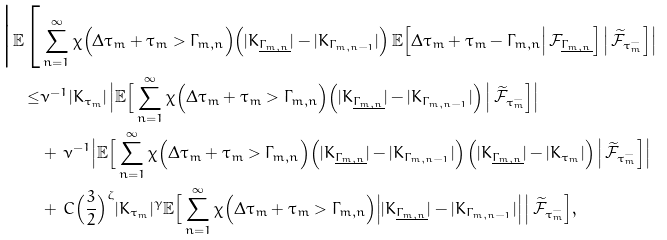<formula> <loc_0><loc_0><loc_500><loc_500>\Big | \mathbb { E } \Big [ & \sum _ { n = 1 } ^ { \infty } \chi \Big ( \Delta \tau _ { m } + \tau _ { m } > \Gamma _ { m , n } \Big ) \Big ( | K _ { \underline { \Gamma _ { m , n } } } | - | K _ { \Gamma _ { m , n - 1 } } | \Big ) \, \mathbb { E } \Big [ \Delta \tau _ { m } + \tau _ { m } - \Gamma _ { m , n } \Big | \, \mathcal { F } _ { \underline { \Gamma _ { m , n } } } \Big ] \, \Big | \, \widetilde { \mathcal { F } } _ { \tau _ { m } ^ { - } } \Big ] \Big | \\ \leq & \nu ^ { - 1 } | K _ { \tau _ { m } } | \, \Big | \mathbb { E } \Big [ \sum _ { n = 1 } ^ { \infty } \chi \Big ( \Delta \tau _ { m } + \tau _ { m } > \Gamma _ { m , n } \Big ) \Big ( | K _ { \underline { \Gamma _ { m , n } } } | - | K _ { \Gamma _ { m , n - 1 } } | \Big ) \, \Big | \, \widetilde { \mathcal { F } } _ { \tau _ { m } ^ { - } } \Big ] \Big | \\ & + \, \nu ^ { - 1 } \Big | \mathbb { E } \Big [ \sum _ { n = 1 } ^ { \infty } \chi \Big ( \Delta \tau _ { m } + \tau _ { m } > \Gamma _ { m , n } \Big ) \Big ( | K _ { \underline { \Gamma _ { m , n } } } | - | K _ { \Gamma _ { m , n - 1 } } | \Big ) \, \Big ( | K _ { \underline { \Gamma _ { m , n } } } | - | K _ { \tau _ { m } } | \Big ) \, \Big | \, \widetilde { \mathcal { F } } _ { \tau _ { m } ^ { - } } \Big ] \Big | \\ & + \, C \Big ( \frac { 3 } { 2 } \Big ) ^ { \zeta } | K _ { \tau _ { m } } | ^ { \gamma } \mathbb { E } \Big [ \sum _ { n = 1 } ^ { \infty } \chi \Big ( \Delta \tau _ { m } + \tau _ { m } > \Gamma _ { m , n } \Big ) \Big | | K _ { \underline { \Gamma _ { m , n } } } | - | K _ { \Gamma _ { m , n - 1 } } | \Big | \, \Big | \, \widetilde { \mathcal { F } } _ { \tau _ { m } ^ { - } } \Big ] ,</formula> 